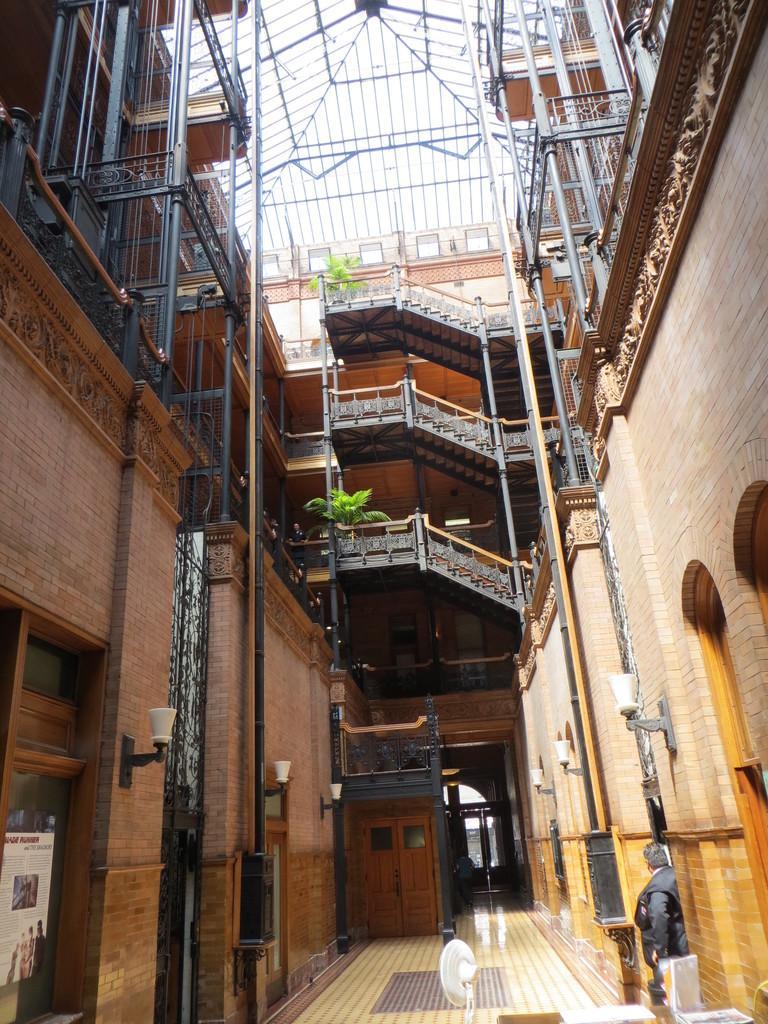Please provide a concise description of this image. In this picture I can see the inside view of building. In the front of this picture I can see the path on which there is a fan and I can see the rods on both sides of this picture and I can see the lights on the walls. In the background I can see the stairs and 2 plants. On the right bottom corner of this image I see a person. 